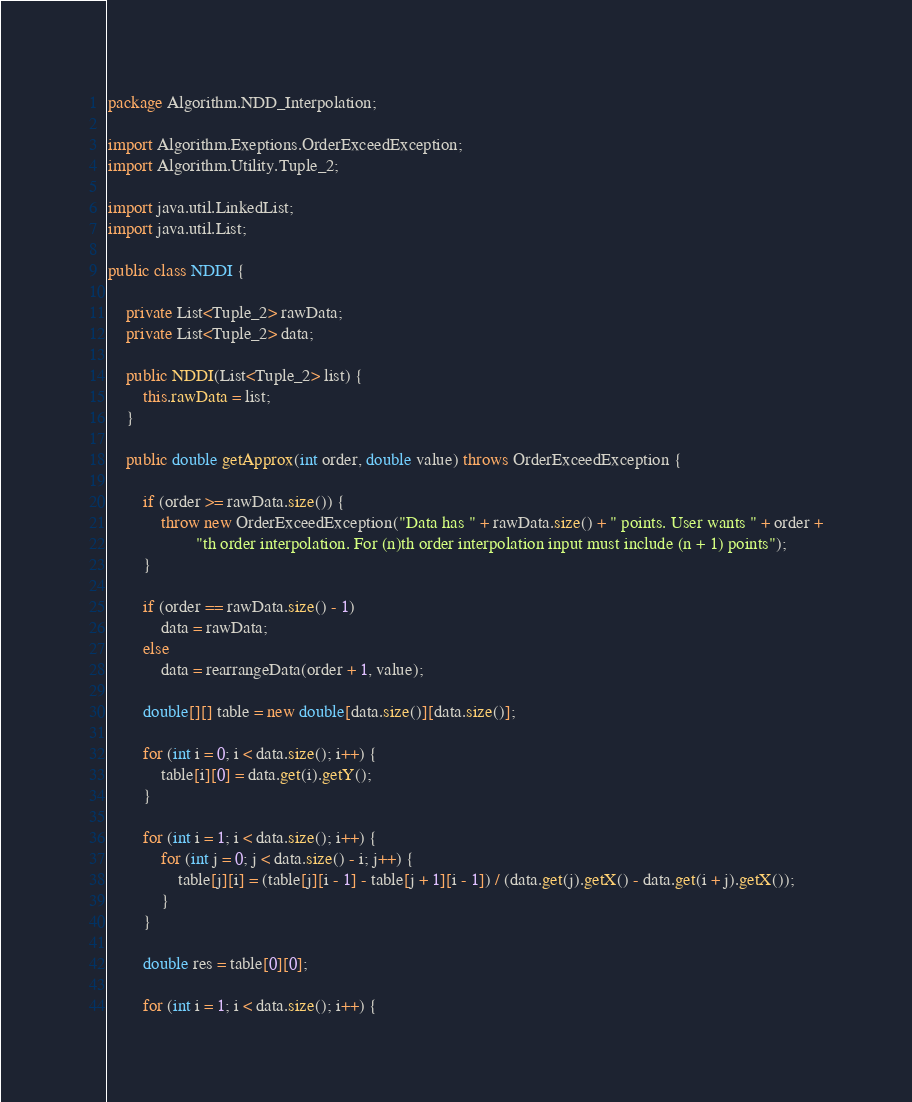Convert code to text. <code><loc_0><loc_0><loc_500><loc_500><_Java_>package Algorithm.NDD_Interpolation;

import Algorithm.Exeptions.OrderExceedException;
import Algorithm.Utility.Tuple_2;

import java.util.LinkedList;
import java.util.List;

public class NDDI {

    private List<Tuple_2> rawData;
    private List<Tuple_2> data;

    public NDDI(List<Tuple_2> list) {
        this.rawData = list;
    }

    public double getApprox(int order, double value) throws OrderExceedException {

        if (order >= rawData.size()) {
            throw new OrderExceedException("Data has " + rawData.size() + " points. User wants " + order +
                    "th order interpolation. For (n)th order interpolation input must include (n + 1) points");
        }

        if (order == rawData.size() - 1)
            data = rawData;
        else
            data = rearrangeData(order + 1, value);

        double[][] table = new double[data.size()][data.size()];

        for (int i = 0; i < data.size(); i++) {
            table[i][0] = data.get(i).getY();
        }

        for (int i = 1; i < data.size(); i++) {
            for (int j = 0; j < data.size() - i; j++) {
                table[j][i] = (table[j][i - 1] - table[j + 1][i - 1]) / (data.get(j).getX() - data.get(i + j).getX());
            }
        }

        double res = table[0][0];

        for (int i = 1; i < data.size(); i++) {</code> 